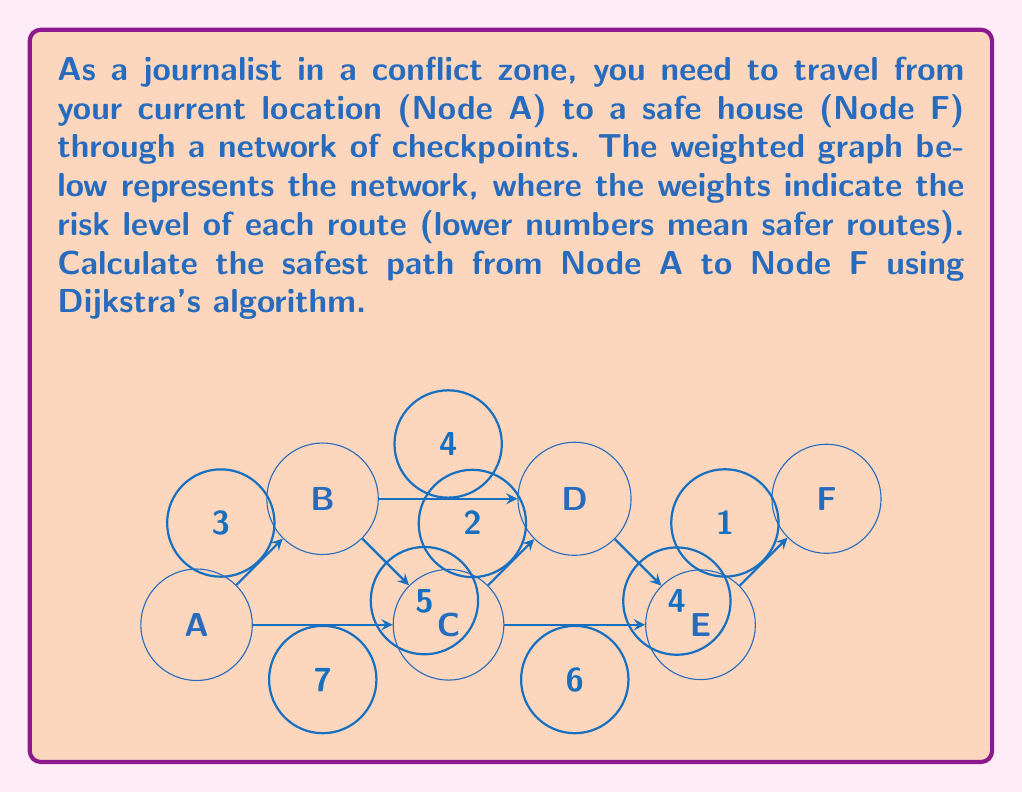What is the answer to this math problem? To solve this problem, we'll use Dijkstra's algorithm to find the shortest (safest) path from Node A to Node F. Here's a step-by-step explanation:

1) Initialize:
   - Set distance to A as 0 and all other nodes as infinity.
   - Set all nodes as unvisited.
   - Set A as the current node.

2) For the current node, consider all unvisited neighbors and calculate their tentative distances.
   - From A: B(3), C(7)

3) Update distances if smaller than the previously recorded distance:
   - B: 3 (smaller than infinity)
   - C: 7 (smaller than infinity)

4) Mark A as visited. B has the smallest tentative distance, so make it the current node.

5) From B, consider unvisited neighbors:
   - C: 3 + 5 = 8 (larger than current 7, don't update)
   - D: 3 + 4 = 7

6) Mark B as visited. C and D both have distance 7. Choose C arbitrarily.

7) From C, consider unvisited neighbors:
   - D: 7 + 2 = 9 (larger than current 7, don't update)
   - E: 7 + 6 = 13

8) Mark C as visited. D has the smallest tentative distance, so it's next.

9) From D, consider unvisited neighbors:
   - E: 7 + 4 = 11 (smaller than current 13, update)

10) Mark D as visited. E is the only unvisited node left (except F).

11) From E, go to F:
    - F: 11 + 1 = 12

12) The algorithm is complete. The shortest path from A to F is found.

The safest path is A → B → D → E → F with a total risk level of 12.
Answer: The safest path is A → B → D → E → F with a total risk level of 12. 